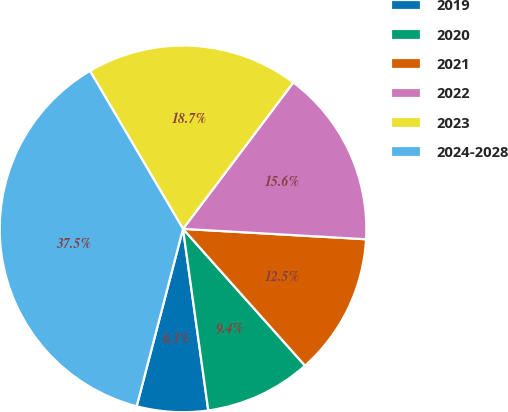<chart> <loc_0><loc_0><loc_500><loc_500><pie_chart><fcel>2019<fcel>2020<fcel>2021<fcel>2022<fcel>2023<fcel>2024-2028<nl><fcel>6.27%<fcel>9.39%<fcel>12.51%<fcel>15.63%<fcel>18.75%<fcel>37.47%<nl></chart> 